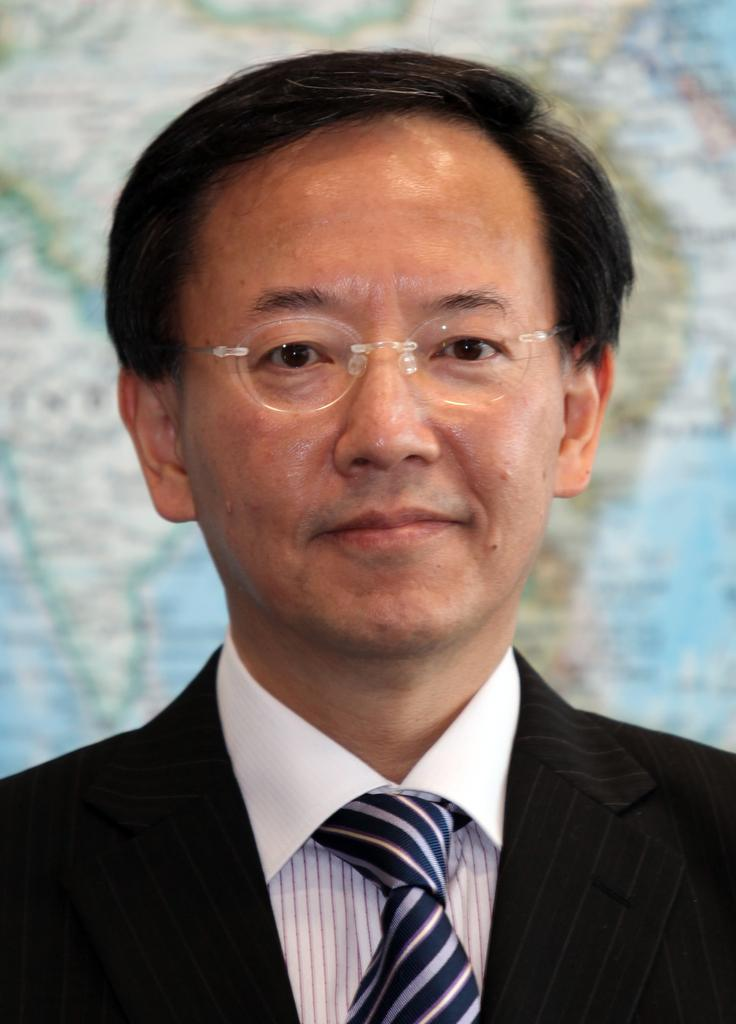Who is present in the image? There is a man in the image. What is the man wearing? The man is wearing a black suit, a tie, and a spectacle. What can be seen in the background of the image? There is a map in the background of the image. How many stamps are on the man's tie in the image? There are no stamps visible on the man's tie in the image. What is the level of noise in the image? The level of noise cannot be determined from the image, as it is a still photograph. 